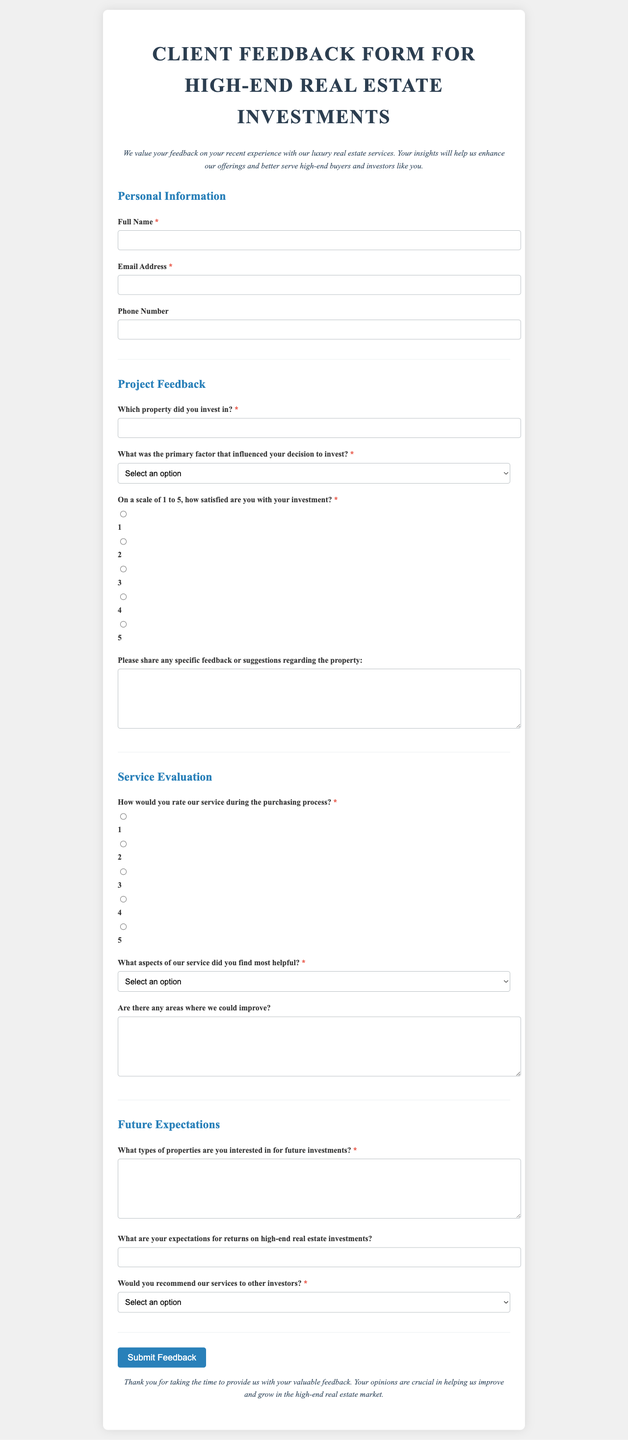What is the document title? The title is the main heading of the document, indicating the purpose of the form.
Answer: Client Feedback Form for High-End Real Estate Investments What is the first section of the form? The first section is where individuals provide their personal details, such as name and contact information.
Answer: Personal Information Which property did the feedback reference? The question asks for a specific property in which the respondent has invested, as required in the survey.
Answer: Which property did you invest in? What are the options for the factor influencing investment decision? This question lists the options available to the respondent to choose from regarding their investment motivation.
Answer: Location, Design and Architecture, Price Point, Expected ROI, Brand Reputation How would you rate your satisfaction on a scale of 1 to 5? This information pertains to how respondents can express their satisfaction level quantitatively within the document.
Answer: 1 to 5 What can respondents input in the "Please share any specific feedback" text area? This area is designated for respondents to provide personal insights or suggestions related to their investment experience.
Answer: Any specific feedback or suggestions regarding the property What is required for the future expectations section? This section prompts respondents to outline their investment interests and expectations moving forward.
Answer: Types of properties for future investments What are the expectations for returns on high-end real estate investments? This question requests information on the anticipated returns that the responder expects from their investments.
Answer: Expectations for returns on high-end real estate investments Would you recommend our services to other investors? This question gauges whether respondents found enough value in the services to refer them to others.
Answer: Definitely, Probably, Not Sure, Probably Not, Definitely Not 